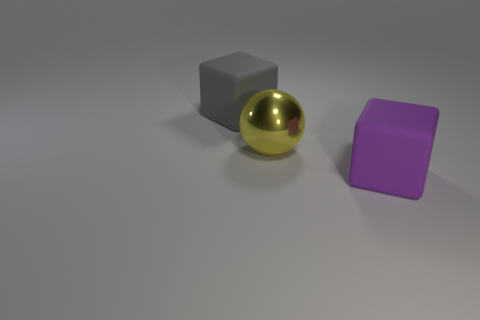Is there any other thing that has the same material as the yellow object?
Your response must be concise. No. What color is the rubber cube that is in front of the matte object to the left of the big rubber cube in front of the yellow thing?
Keep it short and to the point. Purple. Is there another big rubber thing that has the same shape as the gray thing?
Provide a succinct answer. Yes. There is another matte object that is the same size as the purple object; what is its color?
Keep it short and to the point. Gray. What is the cube on the left side of the shiny sphere made of?
Your response must be concise. Rubber. Does the big matte object left of the yellow metallic ball have the same shape as the matte object right of the large yellow metal object?
Make the answer very short. Yes. Are there the same number of large gray objects on the left side of the sphere and large gray cubes?
Offer a very short reply. Yes. How many small green spheres have the same material as the gray thing?
Your answer should be compact. 0. The big thing that is made of the same material as the gray block is what color?
Provide a short and direct response. Purple. Do the yellow metal ball and the matte object in front of the yellow metal ball have the same size?
Provide a short and direct response. Yes. 